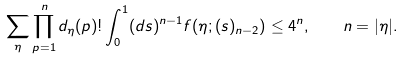<formula> <loc_0><loc_0><loc_500><loc_500>\sum _ { \eta } \prod _ { p = 1 } ^ { n } d _ { \eta } ( p ) ! \int _ { 0 } ^ { 1 } ( d s ) ^ { n - 1 } f ( \eta ; ( s ) _ { n - 2 } ) \leq 4 ^ { n } , \quad n = | \eta | .</formula> 